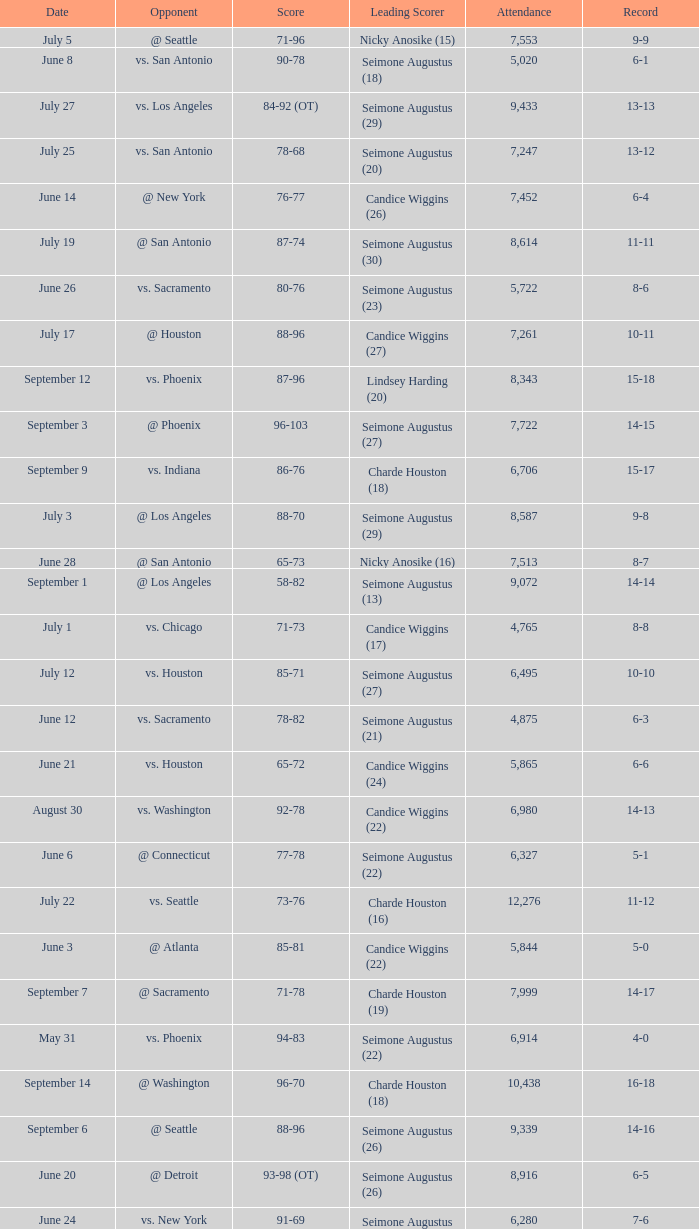What is the score of an opponent against @ houston with a 2-0 record? 98-92 (OT). 